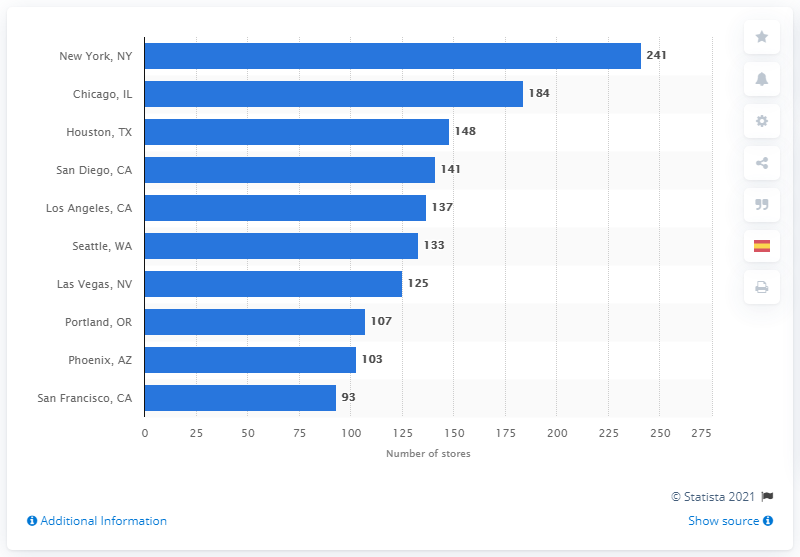Outline some significant characteristics in this image. In 2019, New York City had 241 Starbucks stores. 